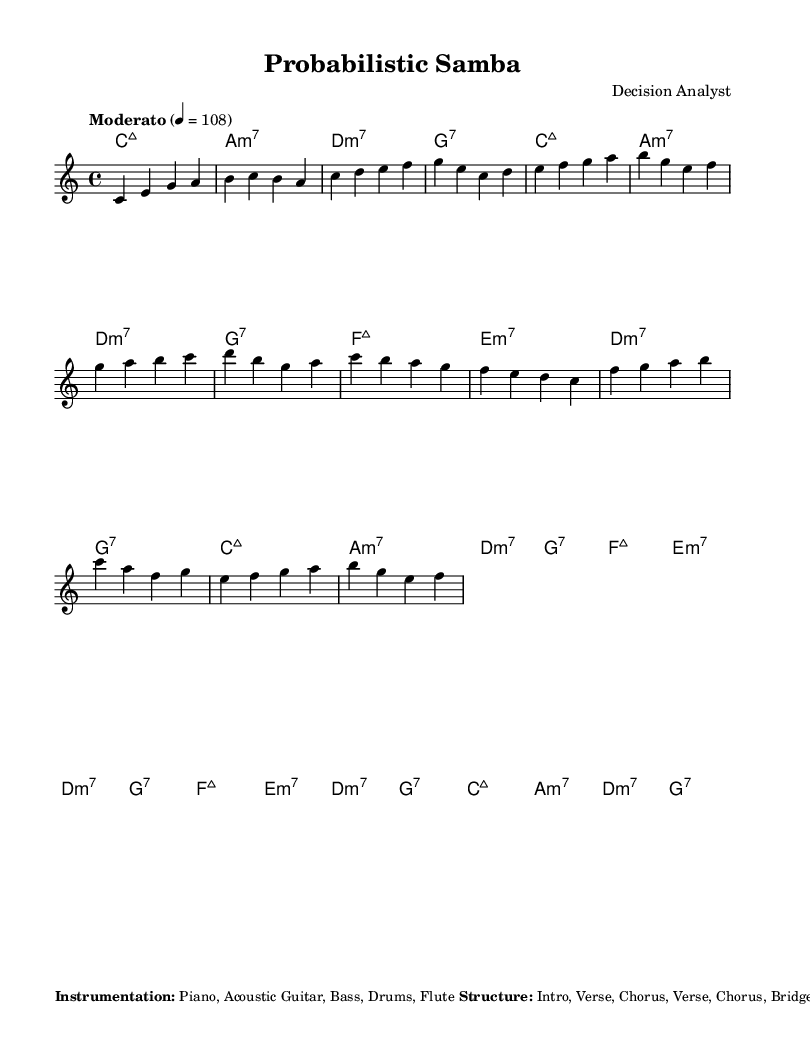What is the key signature of this music? The key signature is C major, which has no sharps or flats noted at the beginning of the sheet music.
Answer: C major What is the time signature of this piece? The time signature is indicated as 4/4, which means there are four beats in each measure and the quarter note gets one beat.
Answer: 4/4 What is the tempo marking for this composition? The tempo is indicated as "Moderato" with a metronome marking of 108, which provides the performer a guideline for playing at a moderate speed.
Answer: Moderato 4 = 108 How many sections does this composition have? The structure of the piece is outlined as "Intro, Verse, Chorus, Verse, Chorus, Bridge, Chorus, Outro", which totals 8 distinct sections.
Answer: 8 What musical pattern is specified for the bass instrument? The bass is noted to have a syncopated pattern that emphasizes the upbeat, indicated by the description provided in the additional notes section.
Answer: Syncopated pattern: 1 - (2) - 3 - 4 - What style of drumming is used in this composition? The drums follow a bossa nova pattern characterized by a light and rhythmic playing style, as detailed in the additional notes section.
Answer: Bossa nova pattern Describe the main purpose of the descending melodies in the bridge? The descending melodies in the bridge are specifically intended to symbolize decreasing probability, reflecting the thematic elements of risk assessment integrated into the music.
Answer: Symbolize decreasing probability 